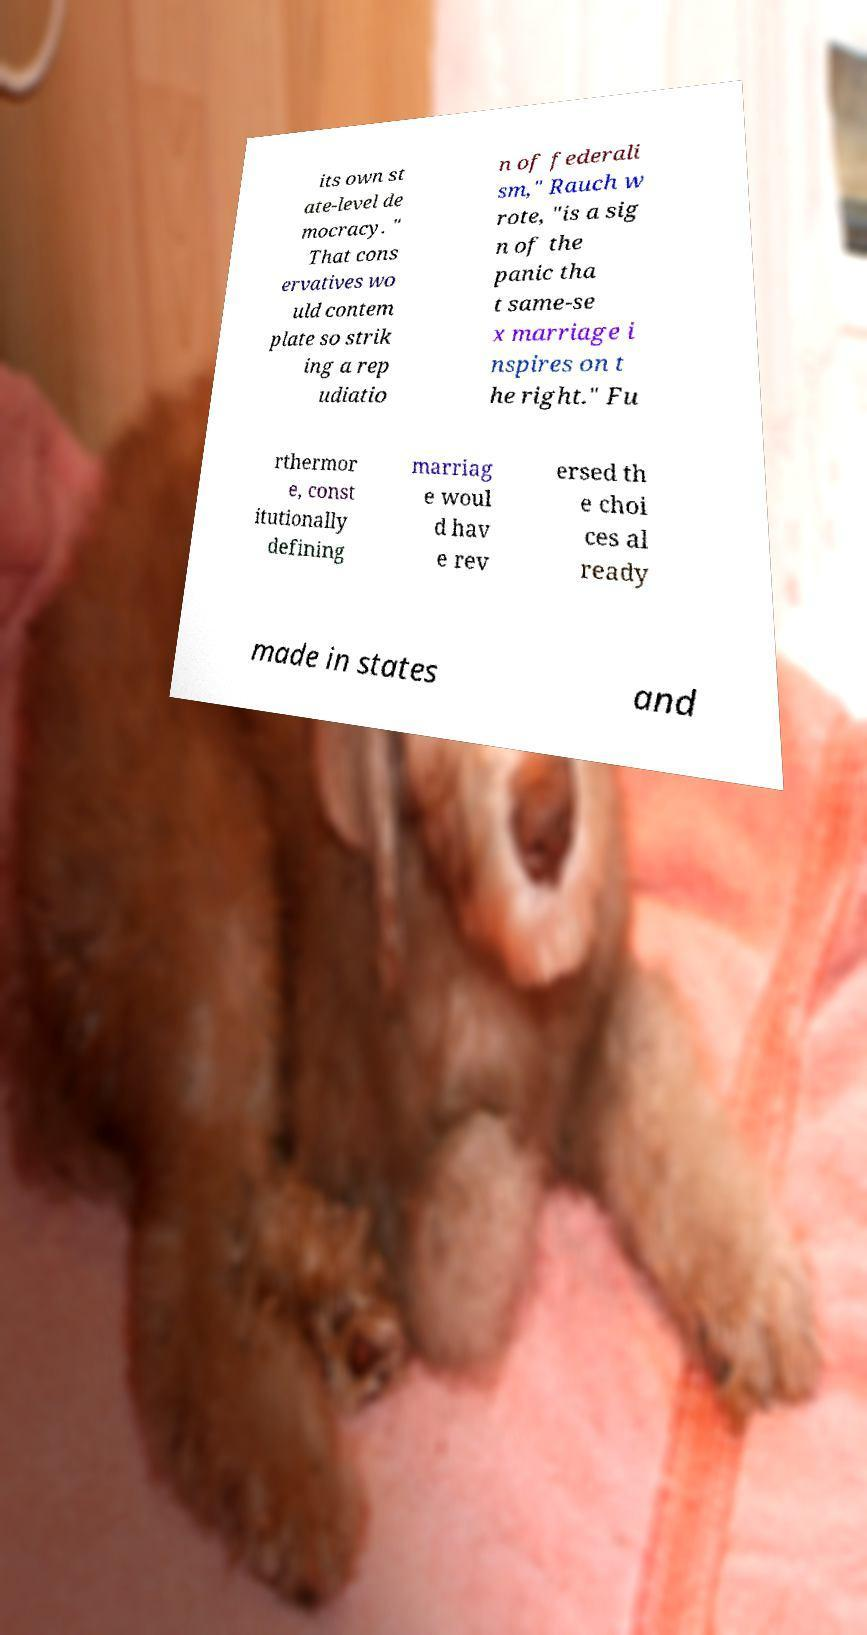Could you assist in decoding the text presented in this image and type it out clearly? its own st ate-level de mocracy. " That cons ervatives wo uld contem plate so strik ing a rep udiatio n of federali sm," Rauch w rote, "is a sig n of the panic tha t same-se x marriage i nspires on t he right." Fu rthermor e, const itutionally defining marriag e woul d hav e rev ersed th e choi ces al ready made in states and 